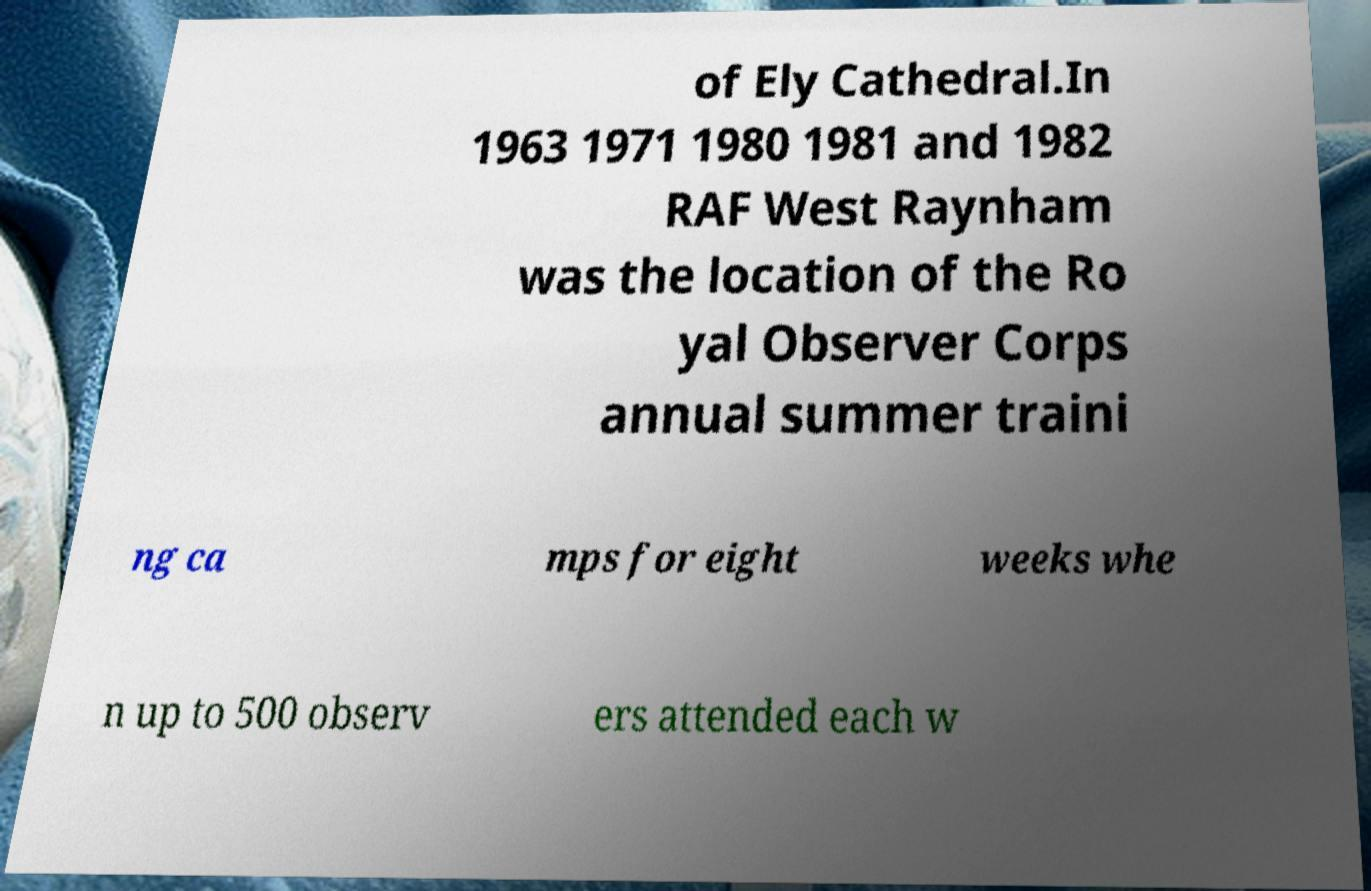Please read and relay the text visible in this image. What does it say? of Ely Cathedral.In 1963 1971 1980 1981 and 1982 RAF West Raynham was the location of the Ro yal Observer Corps annual summer traini ng ca mps for eight weeks whe n up to 500 observ ers attended each w 